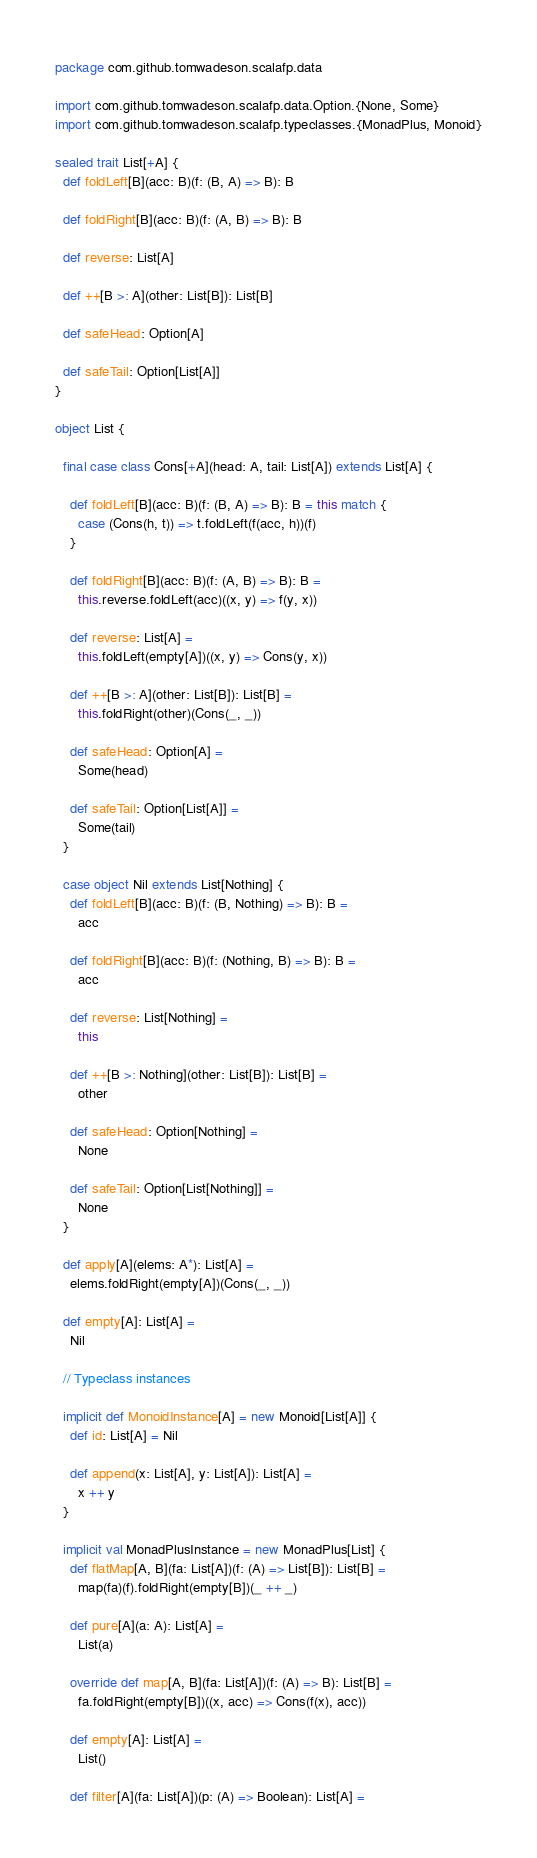Convert code to text. <code><loc_0><loc_0><loc_500><loc_500><_Scala_>package com.github.tomwadeson.scalafp.data

import com.github.tomwadeson.scalafp.data.Option.{None, Some}
import com.github.tomwadeson.scalafp.typeclasses.{MonadPlus, Monoid}

sealed trait List[+A] {
  def foldLeft[B](acc: B)(f: (B, A) => B): B

  def foldRight[B](acc: B)(f: (A, B) => B): B

  def reverse: List[A]

  def ++[B >: A](other: List[B]): List[B]

  def safeHead: Option[A]

  def safeTail: Option[List[A]]
}

object List {

  final case class Cons[+A](head: A, tail: List[A]) extends List[A] {

    def foldLeft[B](acc: B)(f: (B, A) => B): B = this match {
      case (Cons(h, t)) => t.foldLeft(f(acc, h))(f)
    }

    def foldRight[B](acc: B)(f: (A, B) => B): B =
      this.reverse.foldLeft(acc)((x, y) => f(y, x))

    def reverse: List[A] =
      this.foldLeft(empty[A])((x, y) => Cons(y, x))

    def ++[B >: A](other: List[B]): List[B] =
      this.foldRight(other)(Cons(_, _))

    def safeHead: Option[A] =
      Some(head)

    def safeTail: Option[List[A]] =
      Some(tail)
  }

  case object Nil extends List[Nothing] {
    def foldLeft[B](acc: B)(f: (B, Nothing) => B): B =
      acc

    def foldRight[B](acc: B)(f: (Nothing, B) => B): B =
      acc

    def reverse: List[Nothing] =
      this

    def ++[B >: Nothing](other: List[B]): List[B] =
      other

    def safeHead: Option[Nothing] =
      None

    def safeTail: Option[List[Nothing]] =
      None
  }

  def apply[A](elems: A*): List[A] =
    elems.foldRight(empty[A])(Cons(_, _))

  def empty[A]: List[A] =
    Nil

  // Typeclass instances

  implicit def MonoidInstance[A] = new Monoid[List[A]] {
    def id: List[A] = Nil

    def append(x: List[A], y: List[A]): List[A] =
      x ++ y
  }

  implicit val MonadPlusInstance = new MonadPlus[List] {
    def flatMap[A, B](fa: List[A])(f: (A) => List[B]): List[B] =
      map(fa)(f).foldRight(empty[B])(_ ++ _)

    def pure[A](a: A): List[A] =
      List(a)

    override def map[A, B](fa: List[A])(f: (A) => B): List[B] =
      fa.foldRight(empty[B])((x, acc) => Cons(f(x), acc))

    def empty[A]: List[A] =
      List()

    def filter[A](fa: List[A])(p: (A) => Boolean): List[A] =</code> 